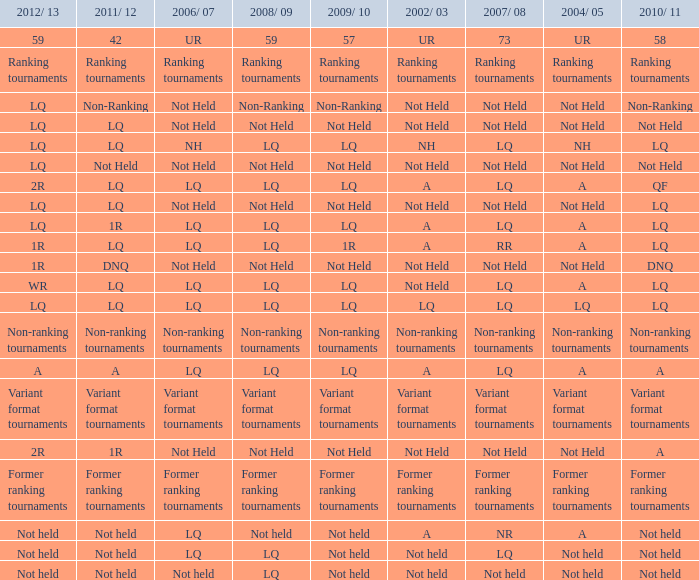Identify the 2008/09 along with 2004/05 in ranking tournaments. Ranking tournaments. 